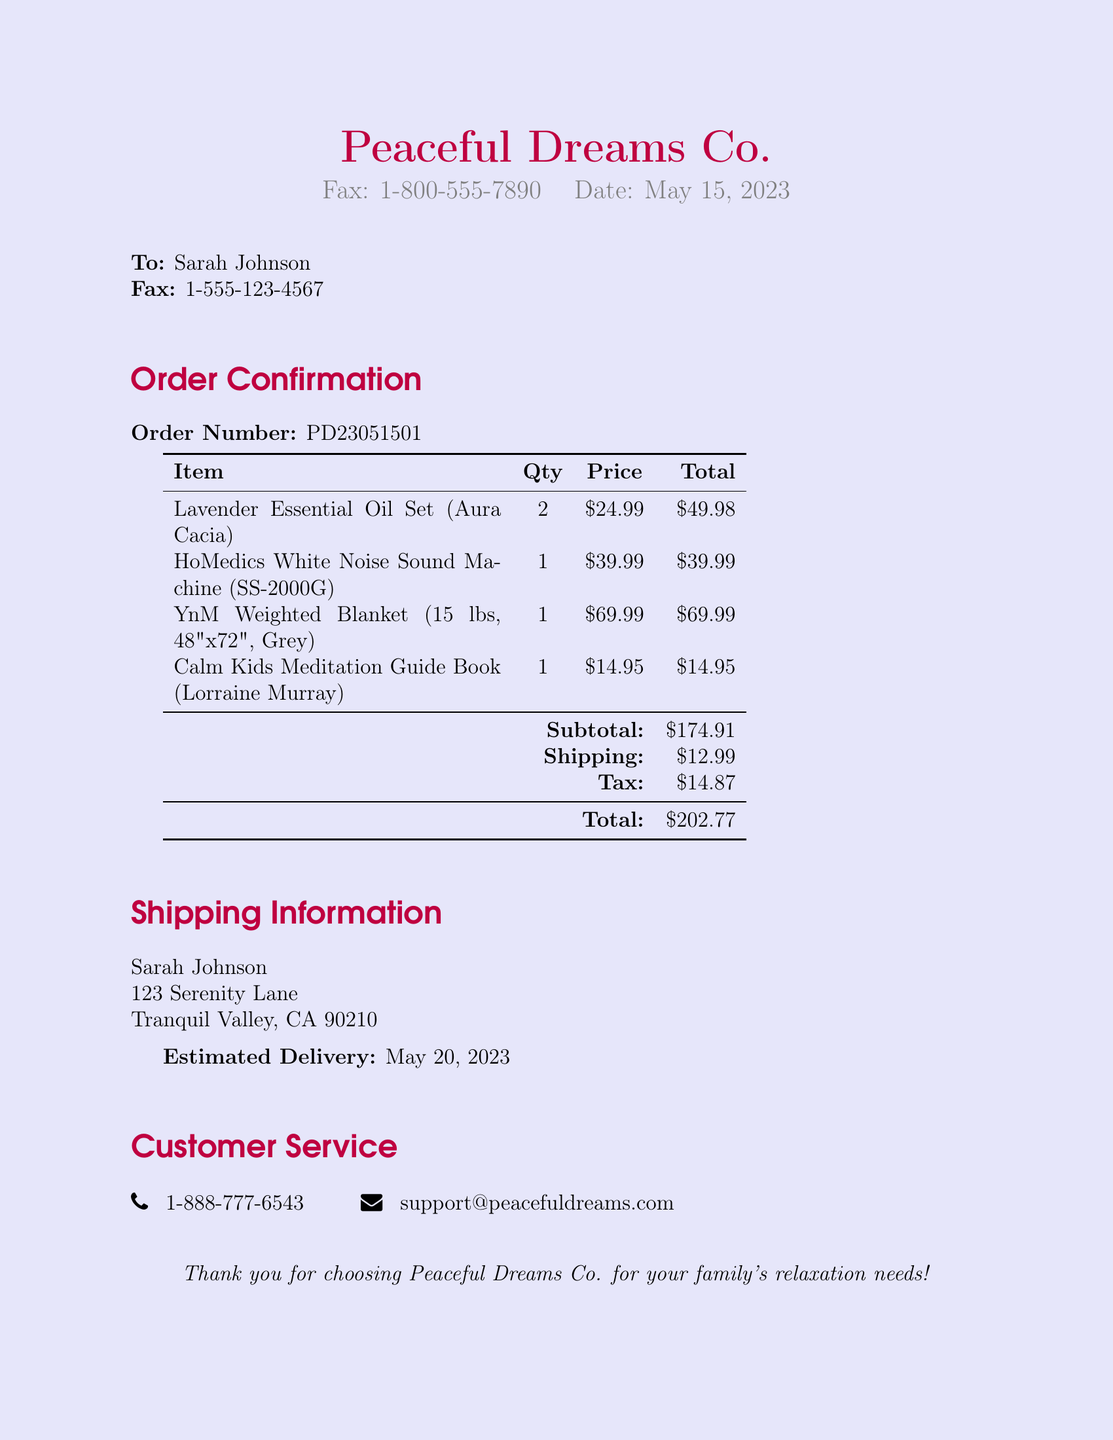What is the order number? The order number is specified in the document as PD23051501.
Answer: PD23051501 Who is the recipient of this fax? The recipient's name is listed at the top of the document as Sarah Johnson.
Answer: Sarah Johnson What is the estimated delivery date? The document mentions that the estimated delivery date for the order is May 20, 2023.
Answer: May 20, 2023 How many Lavender Essential Oil Sets were ordered? The quantity of Lavender Essential Oil Sets is presented in the table as 2.
Answer: 2 What is the total amount charged for the order? The total amount charged is found in the summary of charges, which adds up to $202.77.
Answer: $202.77 What is the price of the HoMedics White Noise Sound Machine? The price for the white noise machine is specified as $39.99.
Answer: $39.99 How much was charged for shipping? Shipping charges are mentioned in the summary and are $12.99.
Answer: $12.99 What is the customer service phone number? The customer service phone number is listed as 1-888-777-6543.
Answer: 1-888-777-6543 Which item has the highest price? The document lists prices for various items, and the highest price is associated with the YnM Weighted Blanket, which costs $69.99.
Answer: YnM Weighted Blanket 